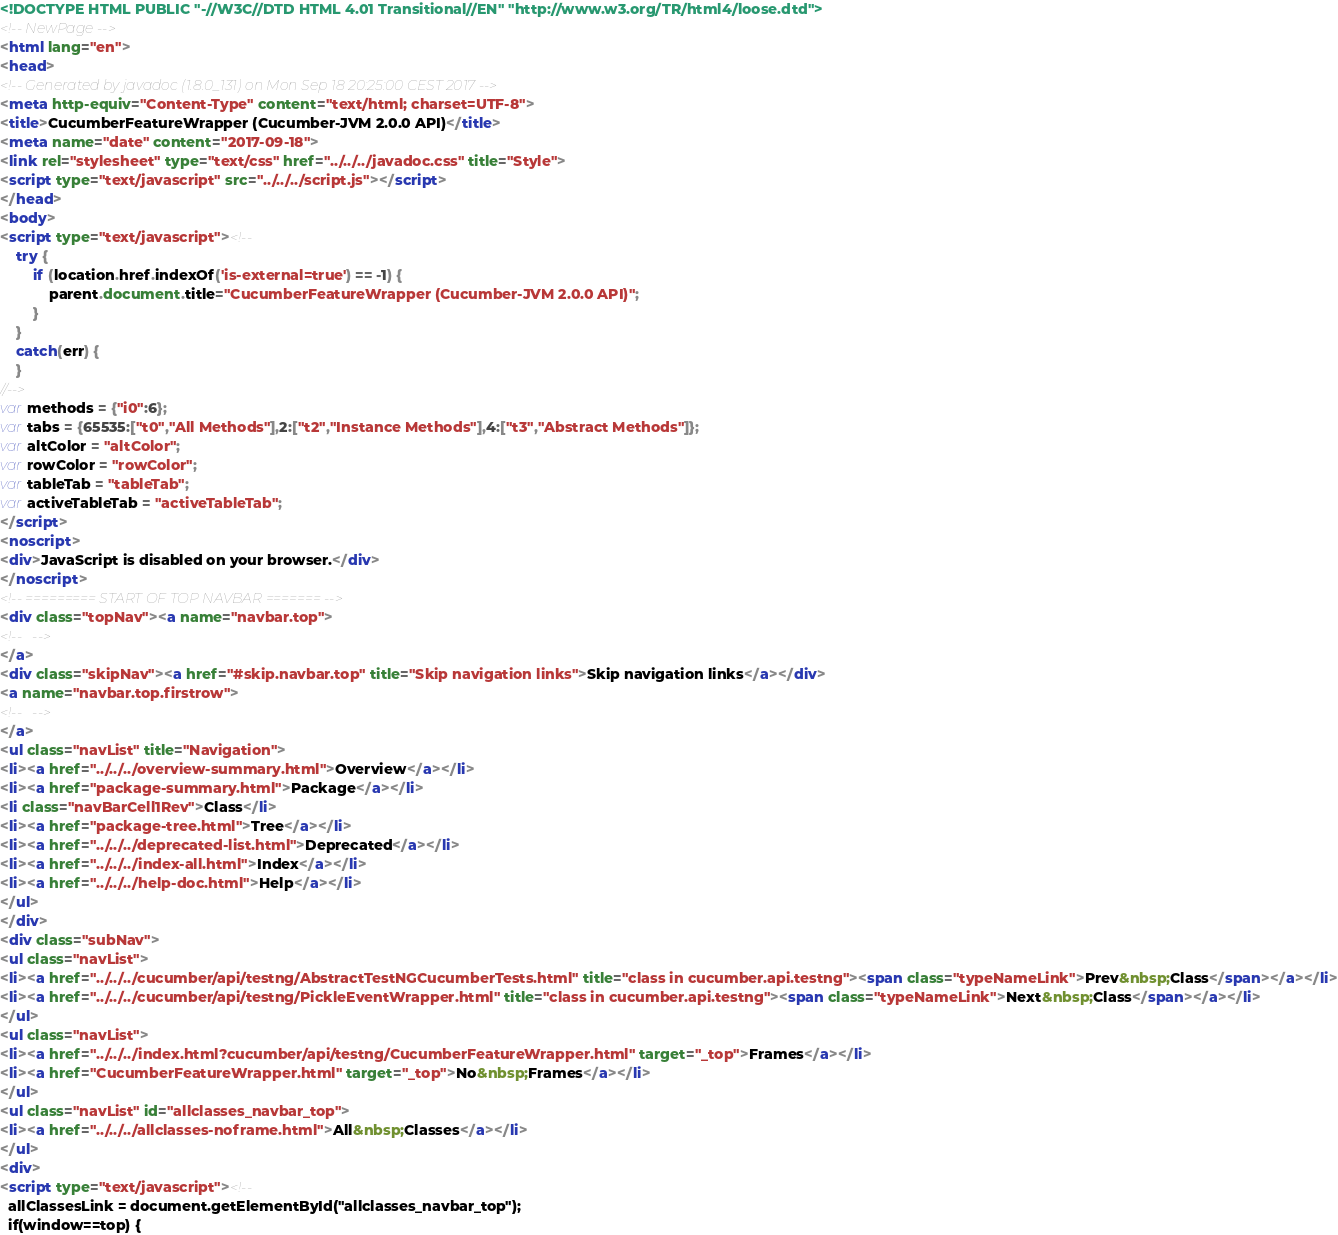<code> <loc_0><loc_0><loc_500><loc_500><_HTML_><!DOCTYPE HTML PUBLIC "-//W3C//DTD HTML 4.01 Transitional//EN" "http://www.w3.org/TR/html4/loose.dtd">
<!-- NewPage -->
<html lang="en">
<head>
<!-- Generated by javadoc (1.8.0_131) on Mon Sep 18 20:25:00 CEST 2017 -->
<meta http-equiv="Content-Type" content="text/html; charset=UTF-8">
<title>CucumberFeatureWrapper (Cucumber-JVM 2.0.0 API)</title>
<meta name="date" content="2017-09-18">
<link rel="stylesheet" type="text/css" href="../../../javadoc.css" title="Style">
<script type="text/javascript" src="../../../script.js"></script>
</head>
<body>
<script type="text/javascript"><!--
    try {
        if (location.href.indexOf('is-external=true') == -1) {
            parent.document.title="CucumberFeatureWrapper (Cucumber-JVM 2.0.0 API)";
        }
    }
    catch(err) {
    }
//-->
var methods = {"i0":6};
var tabs = {65535:["t0","All Methods"],2:["t2","Instance Methods"],4:["t3","Abstract Methods"]};
var altColor = "altColor";
var rowColor = "rowColor";
var tableTab = "tableTab";
var activeTableTab = "activeTableTab";
</script>
<noscript>
<div>JavaScript is disabled on your browser.</div>
</noscript>
<!-- ========= START OF TOP NAVBAR ======= -->
<div class="topNav"><a name="navbar.top">
<!--   -->
</a>
<div class="skipNav"><a href="#skip.navbar.top" title="Skip navigation links">Skip navigation links</a></div>
<a name="navbar.top.firstrow">
<!--   -->
</a>
<ul class="navList" title="Navigation">
<li><a href="../../../overview-summary.html">Overview</a></li>
<li><a href="package-summary.html">Package</a></li>
<li class="navBarCell1Rev">Class</li>
<li><a href="package-tree.html">Tree</a></li>
<li><a href="../../../deprecated-list.html">Deprecated</a></li>
<li><a href="../../../index-all.html">Index</a></li>
<li><a href="../../../help-doc.html">Help</a></li>
</ul>
</div>
<div class="subNav">
<ul class="navList">
<li><a href="../../../cucumber/api/testng/AbstractTestNGCucumberTests.html" title="class in cucumber.api.testng"><span class="typeNameLink">Prev&nbsp;Class</span></a></li>
<li><a href="../../../cucumber/api/testng/PickleEventWrapper.html" title="class in cucumber.api.testng"><span class="typeNameLink">Next&nbsp;Class</span></a></li>
</ul>
<ul class="navList">
<li><a href="../../../index.html?cucumber/api/testng/CucumberFeatureWrapper.html" target="_top">Frames</a></li>
<li><a href="CucumberFeatureWrapper.html" target="_top">No&nbsp;Frames</a></li>
</ul>
<ul class="navList" id="allclasses_navbar_top">
<li><a href="../../../allclasses-noframe.html">All&nbsp;Classes</a></li>
</ul>
<div>
<script type="text/javascript"><!--
  allClassesLink = document.getElementById("allclasses_navbar_top");
  if(window==top) {</code> 